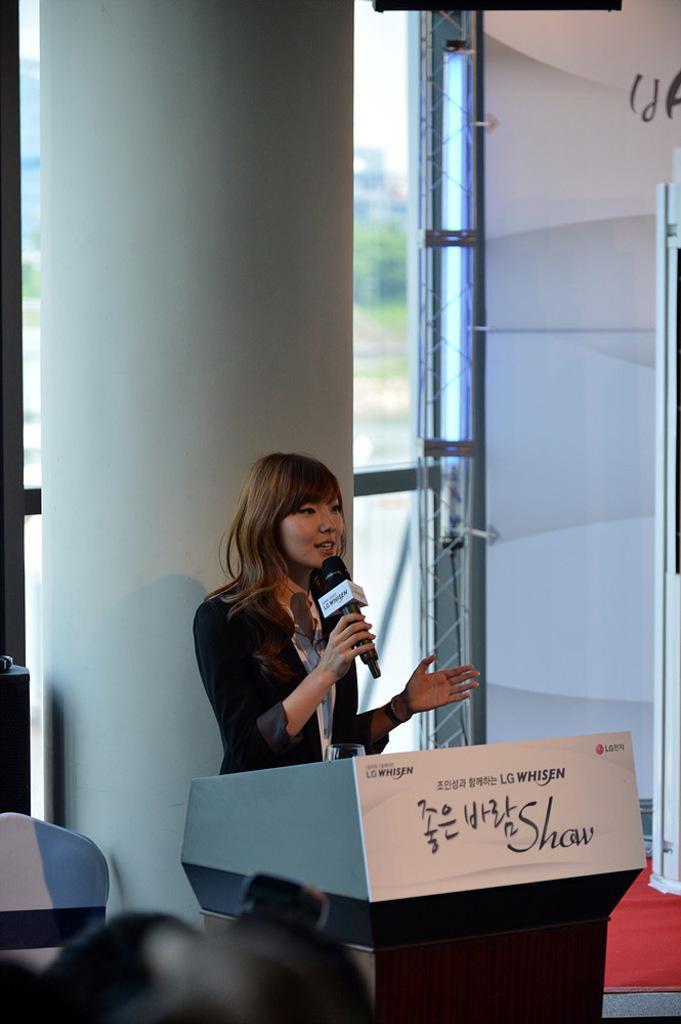Could you give a brief overview of what you see in this image? In this image there is a lady standing and holding a mike in her hand, in front of her there is a table, beside her there is a chair, at the bottom of the image we can see the heads of few people. In the background there is a pole and a glass door of a wall. 